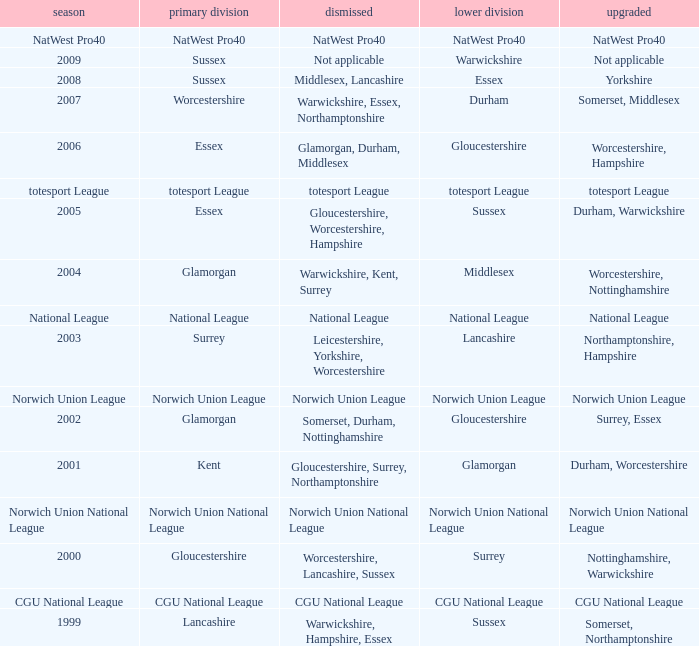What was relegated in the 2006 season? Glamorgan, Durham, Middlesex. 